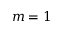Convert formula to latex. <formula><loc_0><loc_0><loc_500><loc_500>m = 1</formula> 